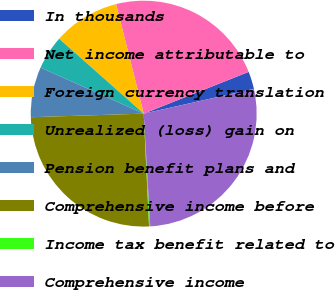Convert chart. <chart><loc_0><loc_0><loc_500><loc_500><pie_chart><fcel>In thousands<fcel>Net income attributable to<fcel>Foreign currency translation<fcel>Unrealized (loss) gain on<fcel>Pension benefit plans and<fcel>Comprehensive income before<fcel>Income tax benefit related to<fcel>Comprehensive income<nl><fcel>2.51%<fcel>22.91%<fcel>9.53%<fcel>4.85%<fcel>7.19%<fcel>25.25%<fcel>0.17%<fcel>27.59%<nl></chart> 